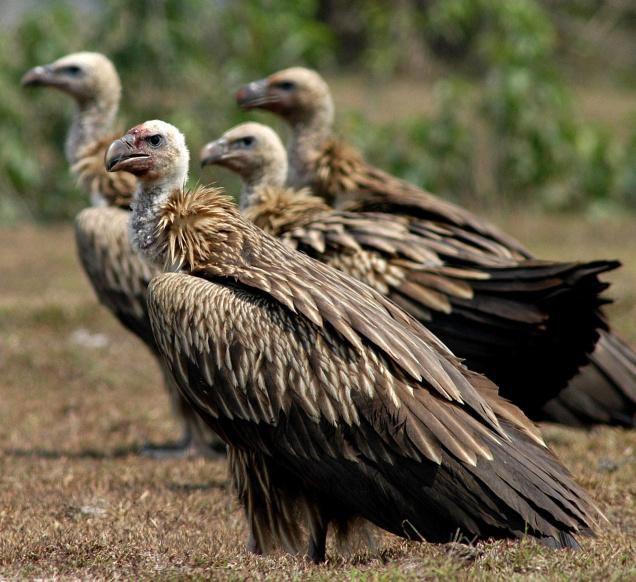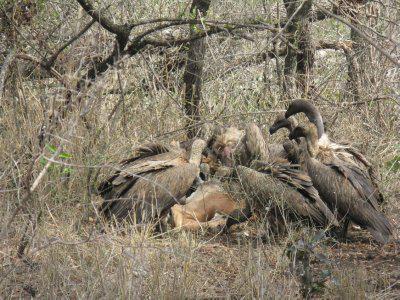The first image is the image on the left, the second image is the image on the right. Examine the images to the left and right. Is the description "The vultures in the image on the right are squabbling over bloody remains in an arid, brown landscape with no green grass." accurate? Answer yes or no. No. 